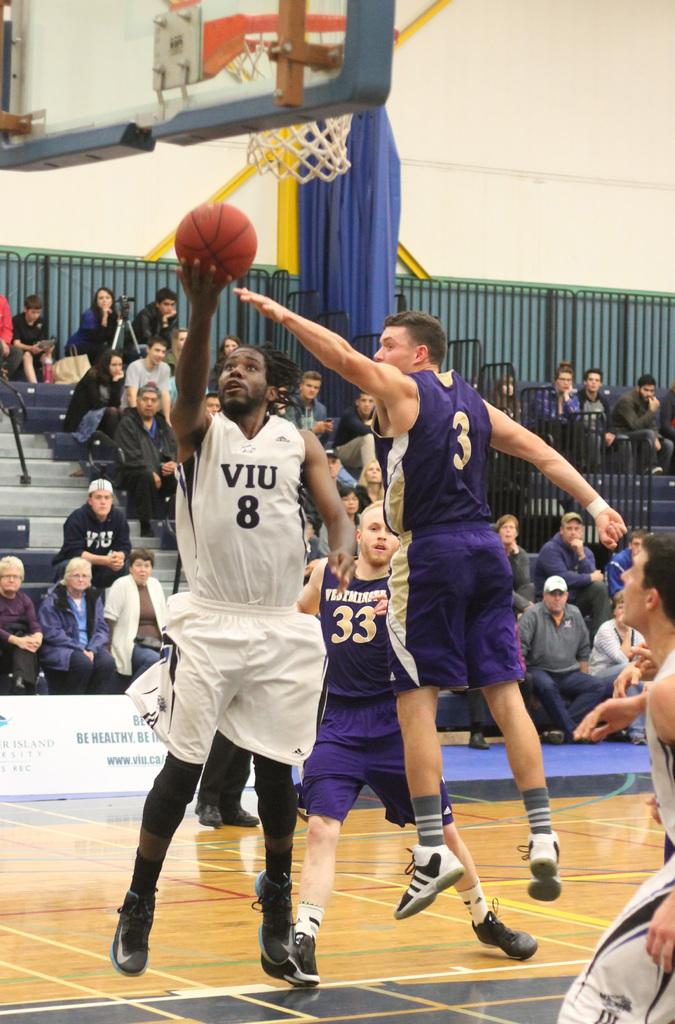Provide a one-sentence caption for the provided image. VIU number 8 attempting to shoot a basketball into the basket. 